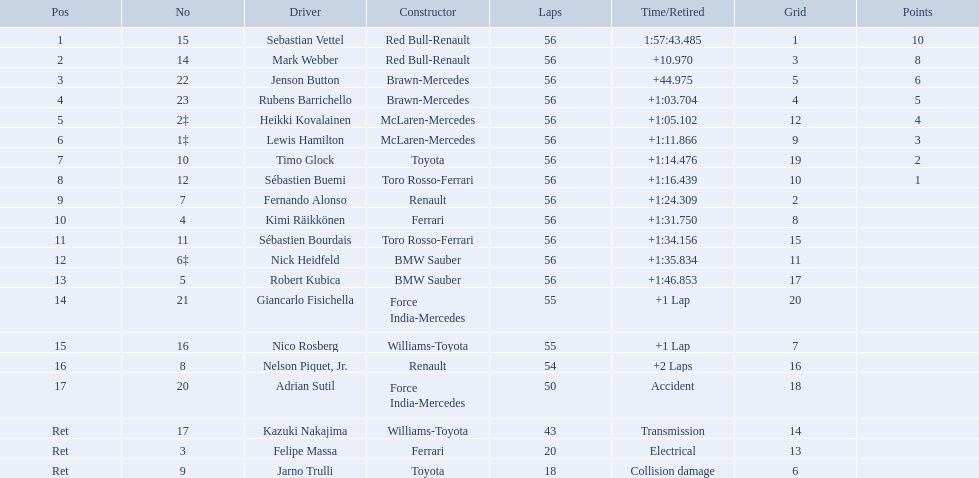Who were all the drivers? Sebastian Vettel, Mark Webber, Jenson Button, Rubens Barrichello, Heikki Kovalainen, Lewis Hamilton, Timo Glock, Sébastien Buemi, Fernando Alonso, Kimi Räikkönen, Sébastien Bourdais, Nick Heidfeld, Robert Kubica, Giancarlo Fisichella, Nico Rosberg, Nelson Piquet, Jr., Adrian Sutil, Kazuki Nakajima, Felipe Massa, Jarno Trulli. Which of these didn't have ferrari as a constructor? Sebastian Vettel, Mark Webber, Jenson Button, Rubens Barrichello, Heikki Kovalainen, Lewis Hamilton, Timo Glock, Sébastien Buemi, Fernando Alonso, Sébastien Bourdais, Nick Heidfeld, Robert Kubica, Giancarlo Fisichella, Nico Rosberg, Nelson Piquet, Jr., Adrian Sutil, Kazuki Nakajima, Jarno Trulli. Which of these was in first place? Sebastian Vettel. Who are all the drivers? Sebastian Vettel, Mark Webber, Jenson Button, Rubens Barrichello, Heikki Kovalainen, Lewis Hamilton, Timo Glock, Sébastien Buemi, Fernando Alonso, Kimi Räikkönen, Sébastien Bourdais, Nick Heidfeld, Robert Kubica, Giancarlo Fisichella, Nico Rosberg, Nelson Piquet, Jr., Adrian Sutil, Kazuki Nakajima, Felipe Massa, Jarno Trulli. What were their finishing times? 1:57:43.485, +10.970, +44.975, +1:03.704, +1:05.102, +1:11.866, +1:14.476, +1:16.439, +1:24.309, +1:31.750, +1:34.156, +1:35.834, +1:46.853, +1 Lap, +1 Lap, +2 Laps, Accident, Transmission, Electrical, Collision damage. Who finished last? Robert Kubica. Why did the  toyota retire Collision damage. What was the drivers name? Jarno Trulli. Who are all the racers? Sebastian Vettel, Mark Webber, Jenson Button, Rubens Barrichello, Heikki Kovalainen, Lewis Hamilton, Timo Glock, Sébastien Buemi, Fernando Alonso, Kimi Räikkönen, Sébastien Bourdais, Nick Heidfeld, Robert Kubica, Giancarlo Fisichella, Nico Rosberg, Nelson Piquet, Jr., Adrian Sutil, Kazuki Nakajima, Felipe Massa, Jarno Trulli. Who were their builders? Red Bull-Renault, Red Bull-Renault, Brawn-Mercedes, Brawn-Mercedes, McLaren-Mercedes, McLaren-Mercedes, Toyota, Toro Rosso-Ferrari, Renault, Ferrari, Toro Rosso-Ferrari, BMW Sauber, BMW Sauber, Force India-Mercedes, Williams-Toyota, Renault, Force India-Mercedes, Williams-Toyota, Ferrari, Toyota. Who was the first mentioned racer to not operate a ferrari? Sebastian Vettel. Which driver resigned due to electrical complications? Felipe Massa. Which driver left the race due to an accident? Adrian Sutil. Would you be able to parse every entry in this table? {'header': ['Pos', 'No', 'Driver', 'Constructor', 'Laps', 'Time/Retired', 'Grid', 'Points'], 'rows': [['1', '15', 'Sebastian Vettel', 'Red Bull-Renault', '56', '1:57:43.485', '1', '10'], ['2', '14', 'Mark Webber', 'Red Bull-Renault', '56', '+10.970', '3', '8'], ['3', '22', 'Jenson Button', 'Brawn-Mercedes', '56', '+44.975', '5', '6'], ['4', '23', 'Rubens Barrichello', 'Brawn-Mercedes', '56', '+1:03.704', '4', '5'], ['5', '2‡', 'Heikki Kovalainen', 'McLaren-Mercedes', '56', '+1:05.102', '12', '4'], ['6', '1‡', 'Lewis Hamilton', 'McLaren-Mercedes', '56', '+1:11.866', '9', '3'], ['7', '10', 'Timo Glock', 'Toyota', '56', '+1:14.476', '19', '2'], ['8', '12', 'Sébastien Buemi', 'Toro Rosso-Ferrari', '56', '+1:16.439', '10', '1'], ['9', '7', 'Fernando Alonso', 'Renault', '56', '+1:24.309', '2', ''], ['10', '4', 'Kimi Räikkönen', 'Ferrari', '56', '+1:31.750', '8', ''], ['11', '11', 'Sébastien Bourdais', 'Toro Rosso-Ferrari', '56', '+1:34.156', '15', ''], ['12', '6‡', 'Nick Heidfeld', 'BMW Sauber', '56', '+1:35.834', '11', ''], ['13', '5', 'Robert Kubica', 'BMW Sauber', '56', '+1:46.853', '17', ''], ['14', '21', 'Giancarlo Fisichella', 'Force India-Mercedes', '55', '+1 Lap', '20', ''], ['15', '16', 'Nico Rosberg', 'Williams-Toyota', '55', '+1 Lap', '7', ''], ['16', '8', 'Nelson Piquet, Jr.', 'Renault', '54', '+2 Laps', '16', ''], ['17', '20', 'Adrian Sutil', 'Force India-Mercedes', '50', 'Accident', '18', ''], ['Ret', '17', 'Kazuki Nakajima', 'Williams-Toyota', '43', 'Transmission', '14', ''], ['Ret', '3', 'Felipe Massa', 'Ferrari', '20', 'Electrical', '13', ''], ['Ret', '9', 'Jarno Trulli', 'Toyota', '18', 'Collision damage', '6', '']]} Which driver quit because of damage from a collision? Jarno Trulli. Which racers participated in the 2009 chinese grand prix? Sebastian Vettel, Mark Webber, Jenson Button, Rubens Barrichello, Heikki Kovalainen, Lewis Hamilton, Timo Glock, Sébastien Buemi, Fernando Alonso, Kimi Räikkönen, Sébastien Bourdais, Nick Heidfeld, Robert Kubica, Giancarlo Fisichella, Nico Rosberg, Nelson Piquet, Jr., Adrian Sutil, Kazuki Nakajima, Felipe Massa, Jarno Trulli. Of the racers in the 2009 chinese grand prix, who completed the event? Sebastian Vettel, Mark Webber, Jenson Button, Rubens Barrichello, Heikki Kovalainen, Lewis Hamilton, Timo Glock, Sébastien Buemi, Fernando Alonso, Kimi Räikkönen, Sébastien Bourdais, Nick Heidfeld, Robert Kubica. Of the racers who completed the event, who had the least fast time? Robert Kubica. Who were the competitors at the 2009 chinese grand prix? Sebastian Vettel, Mark Webber, Jenson Button, Rubens Barrichello, Heikki Kovalainen, Lewis Hamilton, Timo Glock, Sébastien Buemi, Fernando Alonso, Kimi Räikkönen, Sébastien Bourdais, Nick Heidfeld, Robert Kubica, Giancarlo Fisichella, Nico Rosberg, Nelson Piquet, Jr., Adrian Sutil, Kazuki Nakajima, Felipe Massa, Jarno Trulli. Who registered the slowest pace? Robert Kubica. Who were the contestants in the 2009 chinese grand prix? Sebastian Vettel, Mark Webber, Jenson Button, Rubens Barrichello, Heikki Kovalainen, Lewis Hamilton, Timo Glock, Sébastien Buemi, Fernando Alonso, Kimi Räikkönen, Sébastien Bourdais, Nick Heidfeld, Robert Kubica, Giancarlo Fisichella, Nico Rosberg, Nelson Piquet, Jr., Adrian Sutil, Kazuki Nakajima, Felipe Massa, Jarno Trulli. What were their final times? 1:57:43.485, +10.970, +44.975, +1:03.704, +1:05.102, +1:11.866, +1:14.476, +1:16.439, +1:24.309, +1:31.750, +1:34.156, +1:35.834, +1:46.853, +1 Lap, +1 Lap, +2 Laps, Accident, Transmission, Electrical, Collision damage. Which racer suffered from collision damage and exited the race? Jarno Trulli. Which pilots took part in the 2009 chinese grand prix? Sebastian Vettel, Mark Webber, Jenson Button, Rubens Barrichello, Heikki Kovalainen, Lewis Hamilton, Timo Glock, Sébastien Buemi, Fernando Alonso, Kimi Räikkönen, Sébastien Bourdais, Nick Heidfeld, Robert Kubica, Giancarlo Fisichella, Nico Rosberg, Nelson Piquet, Jr., Adrian Sutil, Kazuki Nakajima, Felipe Massa, Jarno Trulli. Of the pilots in the 2009 chinese grand prix, who managed to finish the race? Sebastian Vettel, Mark Webber, Jenson Button, Rubens Barrichello, Heikki Kovalainen, Lewis Hamilton, Timo Glock, Sébastien Buemi, Fernando Alonso, Kimi Räikkönen, Sébastien Bourdais, Nick Heidfeld, Robert Kubica. Of the pilots who finished the race, who registered the slowest time? Robert Kubica. Who are all the participants? Sebastian Vettel, Mark Webber, Jenson Button, Rubens Barrichello, Heikki Kovalainen, Lewis Hamilton, Timo Glock, Sébastien Buemi, Fernando Alonso, Kimi Räikkönen, Sébastien Bourdais, Nick Heidfeld, Robert Kubica, Giancarlo Fisichella, Nico Rosberg, Nelson Piquet, Jr., Adrian Sutil, Kazuki Nakajima, Felipe Massa, Jarno Trulli. What were their final times? 1:57:43.485, +10.970, +44.975, +1:03.704, +1:05.102, +1:11.866, +1:14.476, +1:16.439, +1:24.309, +1:31.750, +1:34.156, +1:35.834, +1:46.853, +1 Lap, +1 Lap, +2 Laps, Accident, Transmission, Electrical, Collision damage. Who concluded last? Robert Kubica. What drivers competed in the 2009 chinese grand prix? Sebastian Vettel, Mark Webber, Jenson Button, Rubens Barrichello, Heikki Kovalainen, Lewis Hamilton, Timo Glock, Sébastien Buemi, Fernando Alonso, Kimi Räikkönen, Sébastien Bourdais, Nick Heidfeld, Robert Kubica, Giancarlo Fisichella, Nico Rosberg, Nelson Piquet, Jr., Adrian Sutil, Kazuki Nakajima, Felipe Massa, Jarno Trulli. Of the competitors in the 2009 chinese grand prix, who finished the race? Sebastian Vettel, Mark Webber, Jenson Button, Rubens Barrichello, Heikki Kovalainen, Lewis Hamilton, Timo Glock, Sébastien Buemi, Fernando Alonso, Kimi Räikkönen, Sébastien Bourdais, Nick Heidfeld, Robert Kubica. Of the competitors who finished the race, who clocked the slowest time? Robert Kubica. Who were all the operators? Sebastian Vettel, Mark Webber, Jenson Button, Rubens Barrichello, Heikki Kovalainen, Lewis Hamilton, Timo Glock, Sébastien Buemi, Fernando Alonso, Kimi Räikkönen, Sébastien Bourdais, Nick Heidfeld, Robert Kubica, Giancarlo Fisichella, Nico Rosberg, Nelson Piquet, Jr., Adrian Sutil, Kazuki Nakajima, Felipe Massa, Jarno Trulli. Which of these didn't have ferrari as a maker? Sebastian Vettel, Mark Webber, Jenson Button, Rubens Barrichello, Heikki Kovalainen, Lewis Hamilton, Timo Glock, Sébastien Buemi, Fernando Alonso, Sébastien Bourdais, Nick Heidfeld, Robert Kubica, Giancarlo Fisichella, Nico Rosberg, Nelson Piquet, Jr., Adrian Sutil, Kazuki Nakajima, Jarno Trulli. Which of these was in the leading spot? Sebastian Vettel. Who were all the participants driving? Sebastian Vettel, Mark Webber, Jenson Button, Rubens Barrichello, Heikki Kovalainen, Lewis Hamilton, Timo Glock, Sébastien Buemi, Fernando Alonso, Kimi Räikkönen, Sébastien Bourdais, Nick Heidfeld, Robert Kubica, Giancarlo Fisichella, Nico Rosberg, Nelson Piquet, Jr., Adrian Sutil, Kazuki Nakajima, Felipe Massa, Jarno Trulli. Among them, who didn't have ferrari as their constructor? Sebastian Vettel, Mark Webber, Jenson Button, Rubens Barrichello, Heikki Kovalainen, Lewis Hamilton, Timo Glock, Sébastien Buemi, Fernando Alonso, Sébastien Bourdais, Nick Heidfeld, Robert Kubica, Giancarlo Fisichella, Nico Rosberg, Nelson Piquet, Jr., Adrian Sutil, Kazuki Nakajima, Jarno Trulli. Lastly, who secured the first position? Sebastian Vettel. Can you parse all the data within this table? {'header': ['Pos', 'No', 'Driver', 'Constructor', 'Laps', 'Time/Retired', 'Grid', 'Points'], 'rows': [['1', '15', 'Sebastian Vettel', 'Red Bull-Renault', '56', '1:57:43.485', '1', '10'], ['2', '14', 'Mark Webber', 'Red Bull-Renault', '56', '+10.970', '3', '8'], ['3', '22', 'Jenson Button', 'Brawn-Mercedes', '56', '+44.975', '5', '6'], ['4', '23', 'Rubens Barrichello', 'Brawn-Mercedes', '56', '+1:03.704', '4', '5'], ['5', '2‡', 'Heikki Kovalainen', 'McLaren-Mercedes', '56', '+1:05.102', '12', '4'], ['6', '1‡', 'Lewis Hamilton', 'McLaren-Mercedes', '56', '+1:11.866', '9', '3'], ['7', '10', 'Timo Glock', 'Toyota', '56', '+1:14.476', '19', '2'], ['8', '12', 'Sébastien Buemi', 'Toro Rosso-Ferrari', '56', '+1:16.439', '10', '1'], ['9', '7', 'Fernando Alonso', 'Renault', '56', '+1:24.309', '2', ''], ['10', '4', 'Kimi Räikkönen', 'Ferrari', '56', '+1:31.750', '8', ''], ['11', '11', 'Sébastien Bourdais', 'Toro Rosso-Ferrari', '56', '+1:34.156', '15', ''], ['12', '6‡', 'Nick Heidfeld', 'BMW Sauber', '56', '+1:35.834', '11', ''], ['13', '5', 'Robert Kubica', 'BMW Sauber', '56', '+1:46.853', '17', ''], ['14', '21', 'Giancarlo Fisichella', 'Force India-Mercedes', '55', '+1 Lap', '20', ''], ['15', '16', 'Nico Rosberg', 'Williams-Toyota', '55', '+1 Lap', '7', ''], ['16', '8', 'Nelson Piquet, Jr.', 'Renault', '54', '+2 Laps', '16', ''], ['17', '20', 'Adrian Sutil', 'Force India-Mercedes', '50', 'Accident', '18', ''], ['Ret', '17', 'Kazuki Nakajima', 'Williams-Toyota', '43', 'Transmission', '14', ''], ['Ret', '3', 'Felipe Massa', 'Ferrari', '20', 'Electrical', '13', ''], ['Ret', '9', 'Jarno Trulli', 'Toyota', '18', 'Collision damage', '6', '']]} Who were the drivers competing in the 2009 chinese grand prix? Sebastian Vettel, Mark Webber, Jenson Button, Rubens Barrichello, Heikki Kovalainen, Lewis Hamilton, Timo Glock, Sébastien Buemi, Fernando Alonso, Kimi Räikkönen, Sébastien Bourdais, Nick Heidfeld, Robert Kubica, Giancarlo Fisichella, Nico Rosberg, Nelson Piquet, Jr., Adrian Sutil, Kazuki Nakajima, Felipe Massa, Jarno Trulli. From those drivers, who reached the finish line? Sebastian Vettel, Mark Webber, Jenson Button, Rubens Barrichello, Heikki Kovalainen, Lewis Hamilton, Timo Glock, Sébastien Buemi, Fernando Alonso, Kimi Räikkönen, Sébastien Bourdais, Nick Heidfeld, Robert Kubica. Among the finishers, who had the least impressive time? Robert Kubica. Who were the competitors in the 2009 chinese grand prix? Sebastian Vettel, Mark Webber, Jenson Button, Rubens Barrichello, Heikki Kovalainen, Lewis Hamilton, Timo Glock, Sébastien Buemi, Fernando Alonso, Kimi Räikkönen, Sébastien Bourdais, Nick Heidfeld, Robert Kubica, Giancarlo Fisichella, Nico Rosberg, Nelson Piquet, Jr., Adrian Sutil, Kazuki Nakajima, Felipe Massa, Jarno Trulli. Of those drivers, who successfully finished the race? Sebastian Vettel, Mark Webber, Jenson Button, Rubens Barrichello, Heikki Kovalainen, Lewis Hamilton, Timo Glock, Sébastien Buemi, Fernando Alonso, Kimi Räikkönen, Sébastien Bourdais, Nick Heidfeld, Robert Kubica. From the ones who finished, who registered the lowest speed? Robert Kubica. 